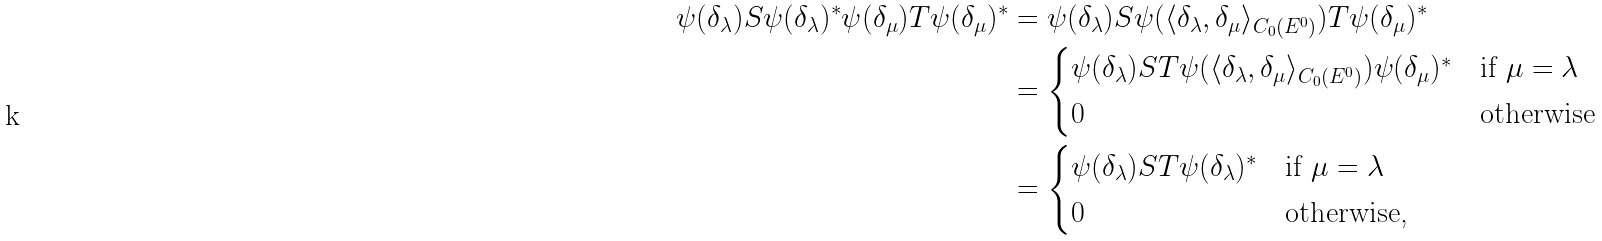Convert formula to latex. <formula><loc_0><loc_0><loc_500><loc_500>\psi ( \delta _ { \lambda } ) S \psi ( \delta _ { \lambda } ) ^ { * } \psi ( \delta _ { \mu } ) T \psi ( \delta _ { \mu } ) ^ { * } & = \psi ( \delta _ { \lambda } ) S \psi ( \langle \delta _ { \lambda } , \delta _ { \mu } \rangle _ { C _ { 0 } ( E ^ { 0 } ) } ) T \psi ( \delta _ { \mu } ) ^ { * } \\ & = \begin{cases} \psi ( \delta _ { \lambda } ) S T \psi ( \langle \delta _ { \lambda } , \delta _ { \mu } \rangle _ { C _ { 0 } ( E ^ { 0 } ) } ) \psi ( \delta _ { \mu } ) ^ { * } & \text {if $\mu=\lambda$} \\ 0 & \text {otherwise} \end{cases} \\ & = \begin{cases} \psi ( \delta _ { \lambda } ) S T \psi ( \delta _ { \lambda } ) ^ { * } & \text {if $\mu=\lambda$} \\ 0 & \text {otherwise,} \end{cases}</formula> 